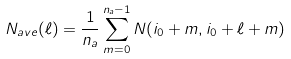Convert formula to latex. <formula><loc_0><loc_0><loc_500><loc_500>N _ { a v e } ( \ell ) = \frac { 1 } { n _ { a } } \sum _ { m = 0 } ^ { n _ { a } - 1 } N ( i _ { 0 } + m , i _ { 0 } + \ell + m )</formula> 